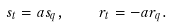<formula> <loc_0><loc_0><loc_500><loc_500>s _ { t } = a s _ { q } , \quad r _ { t } = - a r _ { q } .</formula> 